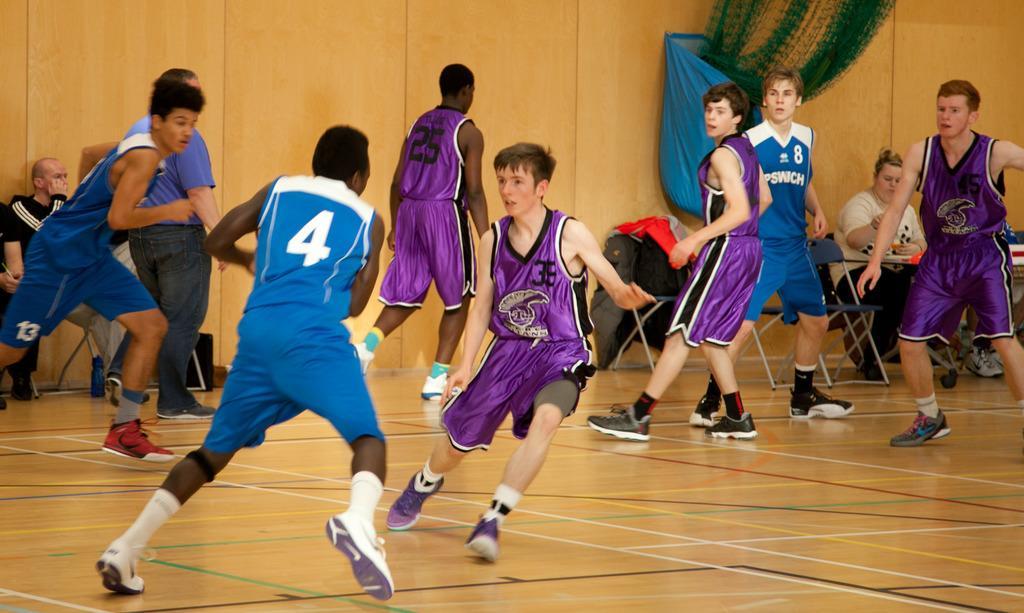Can you describe this image briefly? There are people in motion and few people sitting on chairs, in front of this woman we can see objects on the table. We can see cloth on a chair. We can see net, cover and wall. We can see objects on the floor. 